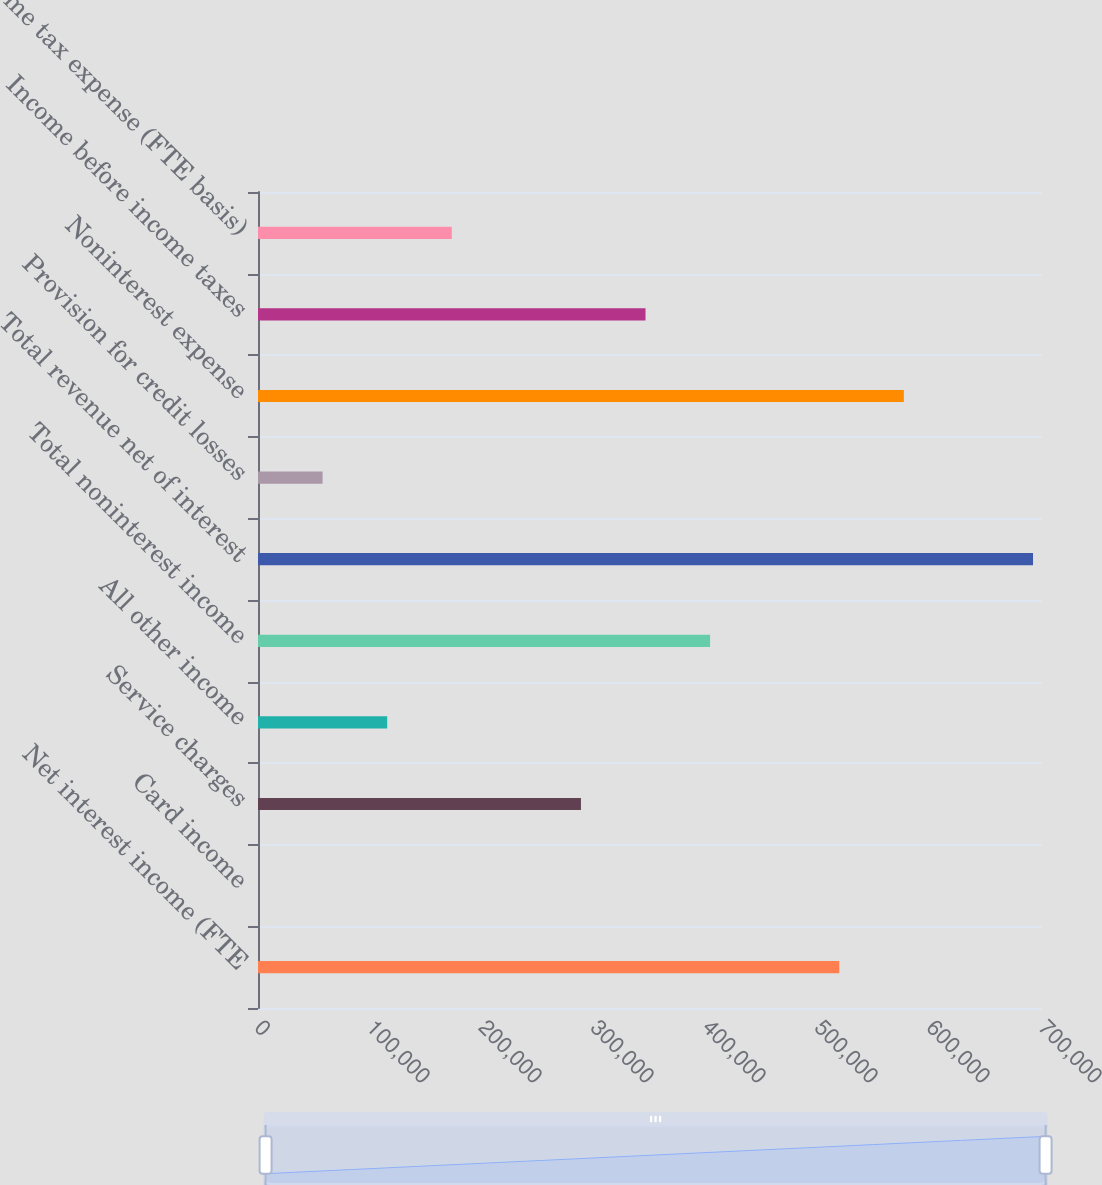Convert chart to OTSL. <chart><loc_0><loc_0><loc_500><loc_500><bar_chart><fcel>Net interest income (FTE<fcel>Card income<fcel>Service charges<fcel>All other income<fcel>Total noninterest income<fcel>Total revenue net of interest<fcel>Provision for credit losses<fcel>Noninterest expense<fcel>Income before income taxes<fcel>Income tax expense (FTE basis)<nl><fcel>518989<fcel>11<fcel>288332<fcel>115339<fcel>403660<fcel>691981<fcel>57675.2<fcel>576653<fcel>345996<fcel>173004<nl></chart> 